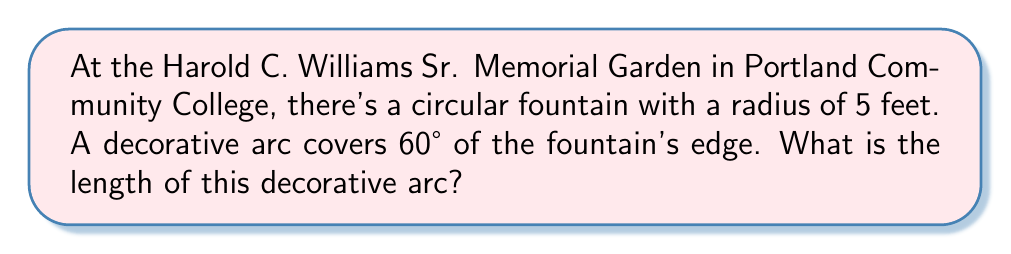Teach me how to tackle this problem. Let's approach this step-by-step:

1) The formula for arc length is:
   $$s = r\theta$$
   where $s$ is the arc length, $r$ is the radius, and $\theta$ is the central angle in radians.

2) We're given the radius $r = 5$ feet and the central angle of 60°.

3) However, we need to convert 60° to radians:
   $$\theta = 60° \times \frac{\pi}{180°} = \frac{\pi}{3} \text{ radians}$$

4) Now we can substitute these values into our formula:
   $$s = r\theta = 5 \times \frac{\pi}{3}$$

5) Simplifying:
   $$s = \frac{5\pi}{3} \text{ feet}$$

6) If we want to calculate this numerically:
   $$s \approx 5.236 \text{ feet}$$

[asy]
import geometry;

size(100);
pair O = (0,0);
real r = 5;
path c = circle(O, r);
draw(c);
draw(O--dir(60)*r);
draw(O--dir(0)*r);
draw(arc(O, r, 0, 60), linewidth(2));
label("60°", O, dir(30));
label("r = 5 ft", O--0.5*dir(0)*r, S);
[/asy]
Answer: $\frac{5\pi}{3}$ feet 